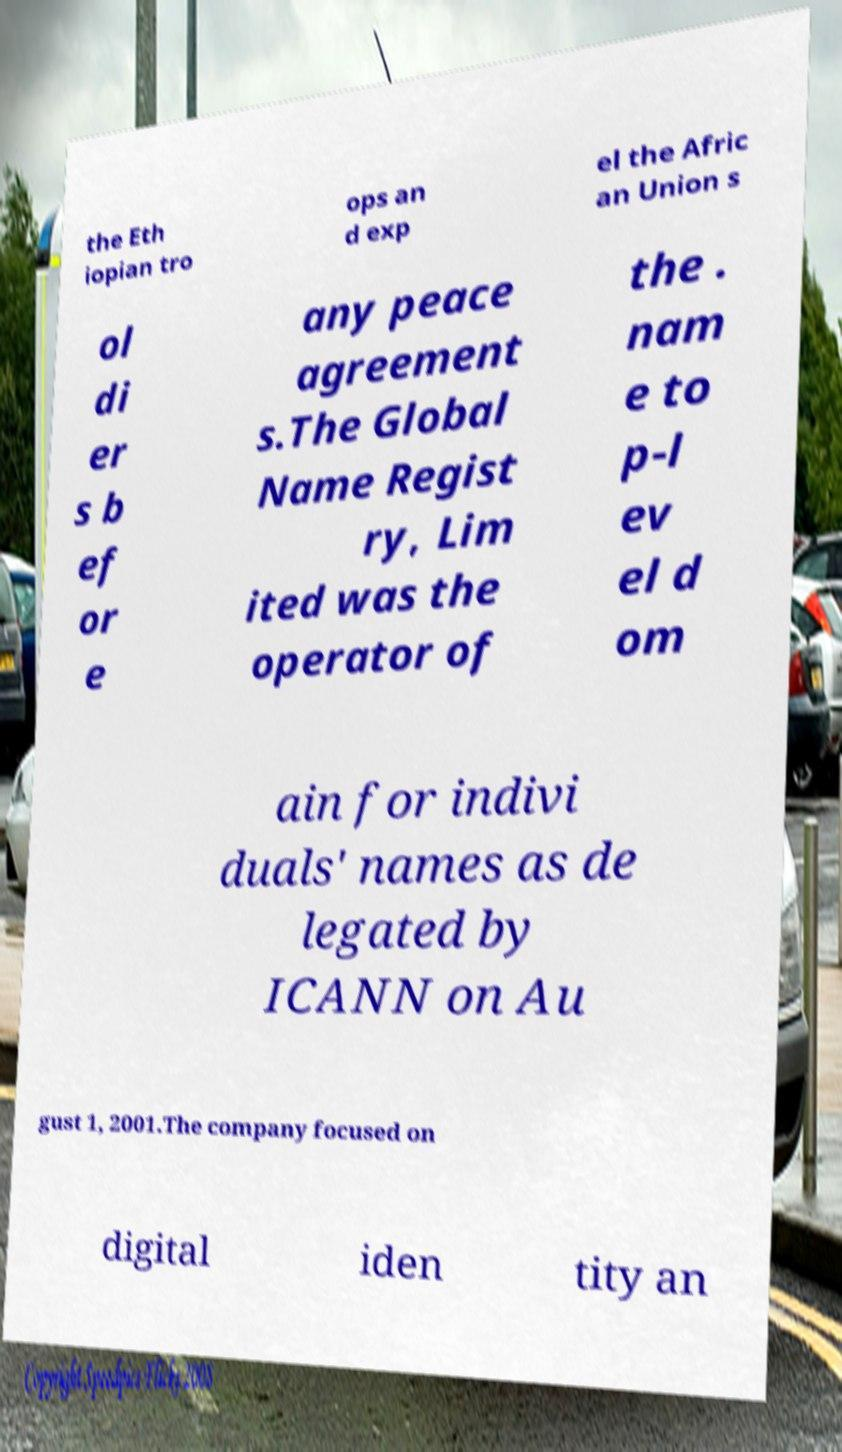Please read and relay the text visible in this image. What does it say? the Eth iopian tro ops an d exp el the Afric an Union s ol di er s b ef or e any peace agreement s.The Global Name Regist ry, Lim ited was the operator of the . nam e to p-l ev el d om ain for indivi duals' names as de legated by ICANN on Au gust 1, 2001.The company focused on digital iden tity an 